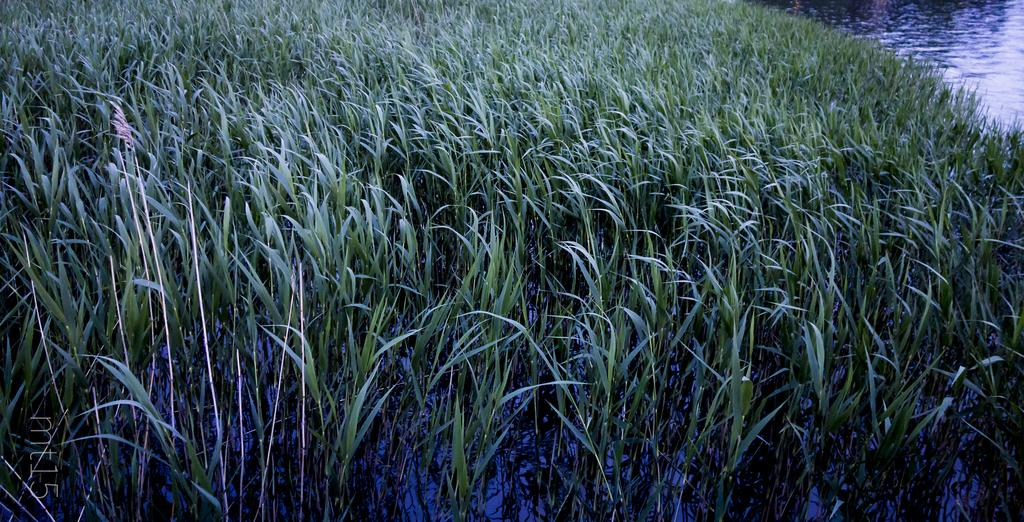What type of vegetation can be seen in the image? There is green-colored grass in the image. What natural element is also visible in the image? There is water visible in the image. What type of credit card is visible in the image? There is no credit card present in the image. How many eggs are visible in the image? There are no eggs present in the image. What type of balls are being used in the image? There are no balls present in the image. 